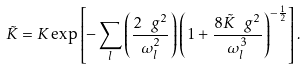Convert formula to latex. <formula><loc_0><loc_0><loc_500><loc_500>\tilde { K } = K \exp \left [ - \sum _ { l } \left ( \frac { 2 \ g ^ { 2 } } { \omega _ { l } ^ { 2 } } \right ) \left ( 1 + \frac { 8 \tilde { K } \ g ^ { 2 } } { \omega _ { l } ^ { 3 } } \right ) ^ { - \frac { 1 } { 2 } } \right ] .</formula> 